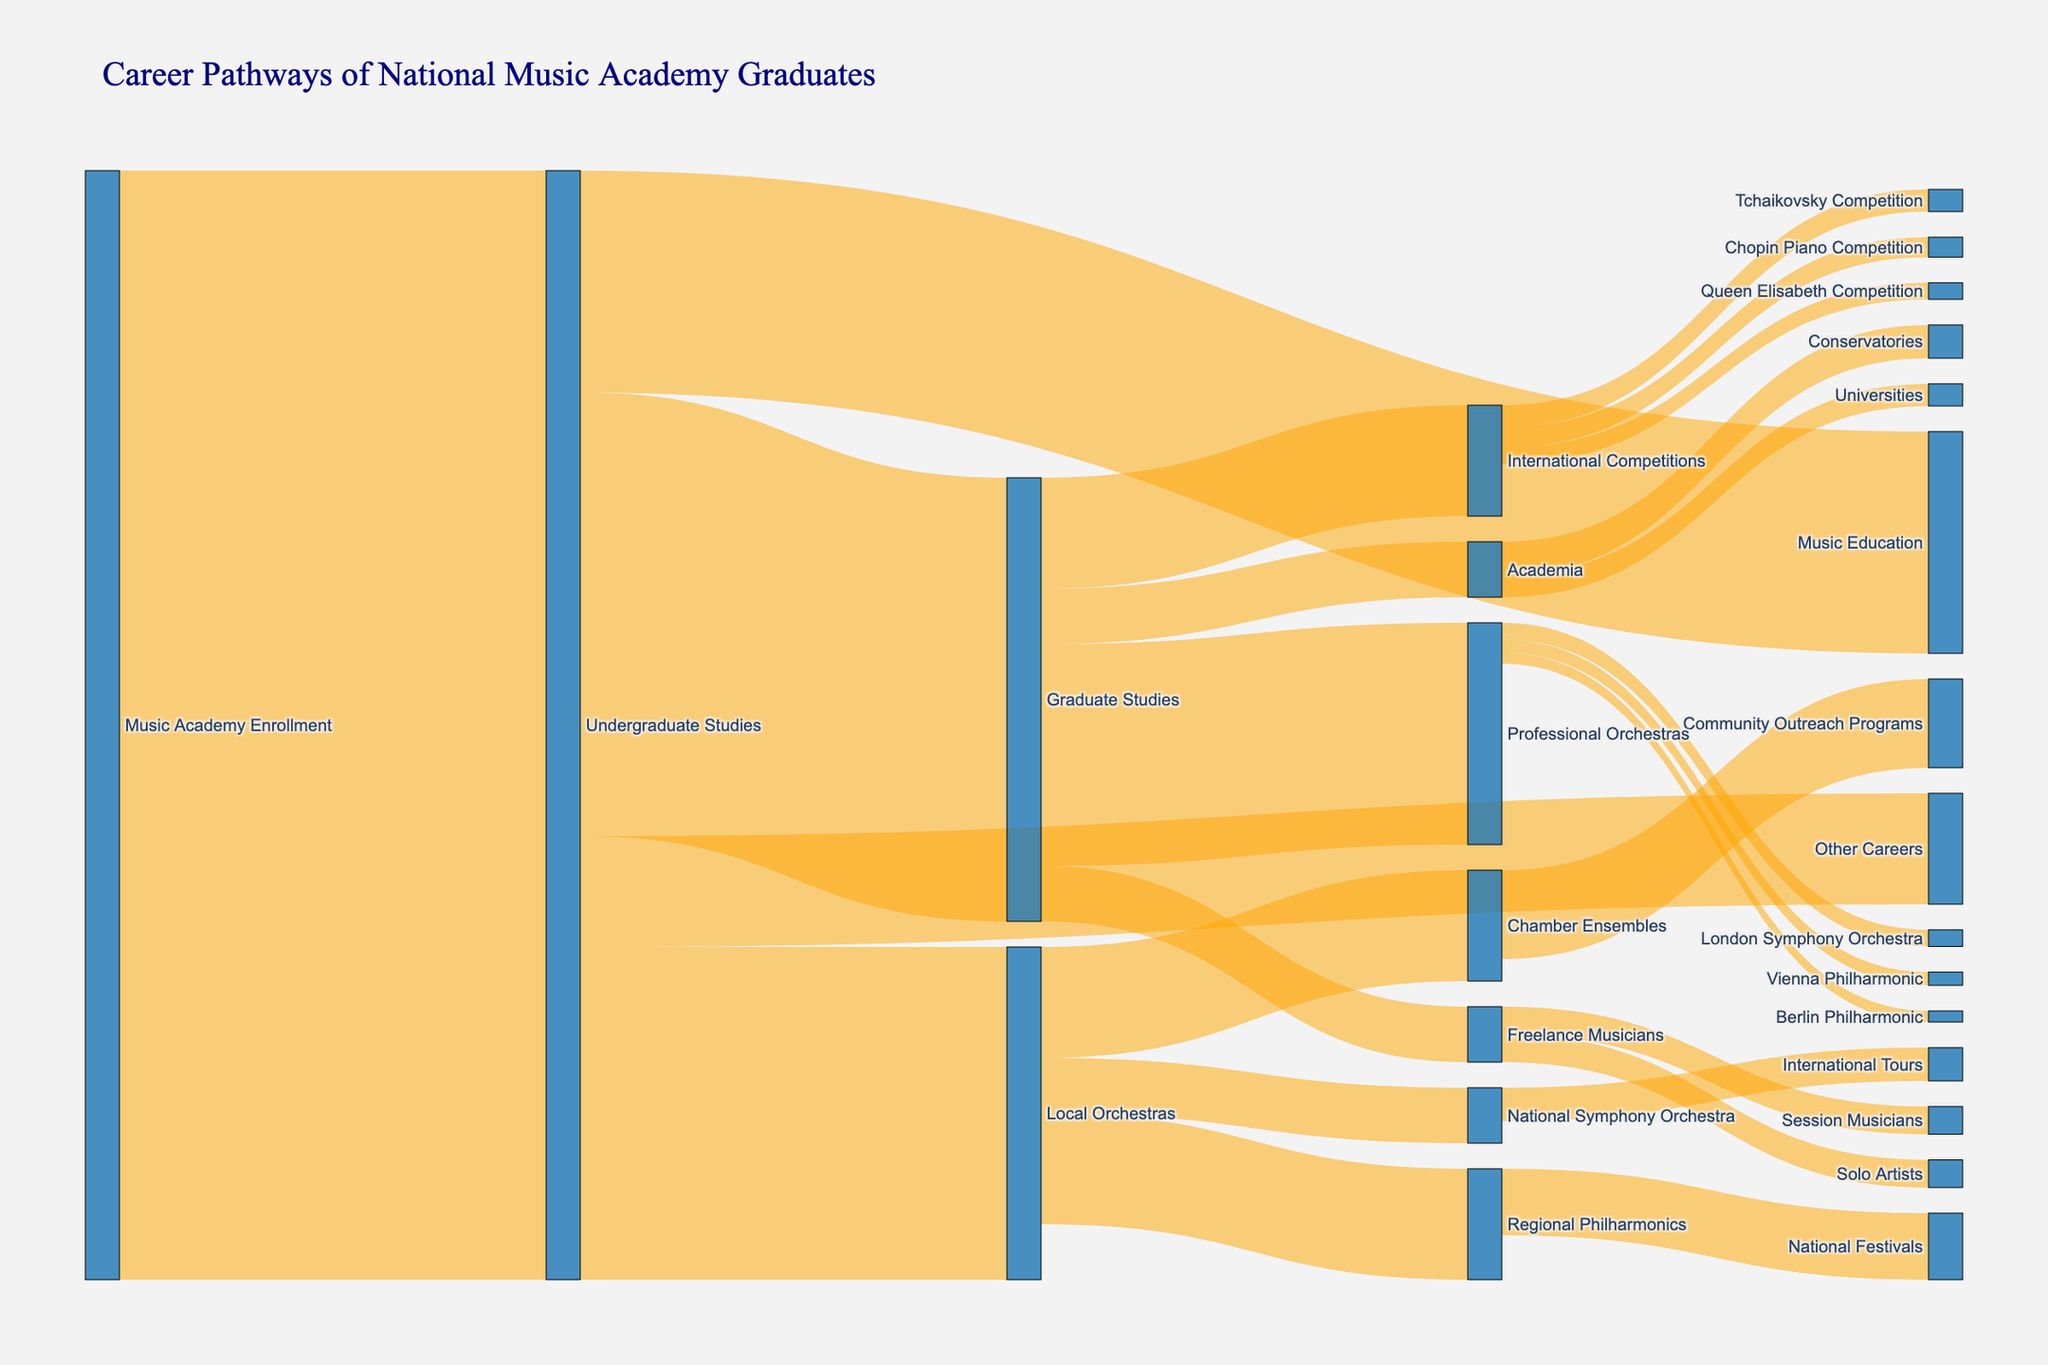What's the title of the figure? The title is at the top of the figure, usually in a larger font size and different color to stand out. It serves as a summary of what the diagram is about.
Answer: Career Pathways of National Music Academy Graduates What's the total number of graduates who pursued Music Education after their undergraduate studies? To find this, look under the "Undergraduate Studies" node and add the value that leads to "Music Education."
Answer: 200 How many graduates moved from Local Orchestras to National Symphony Orchestra? Follow the link from "Local Orchestras" to "National Symphony Orchestra" and read the value associated with that link.
Answer: 50 What is the total number of graduates who joined Professional Orchestras after Graduate Studies? To find this, find the node "Graduate Studies" and sum the values of all links targeting "Professional Orchestras."
Answer: 200 How many graduates advanced from International Competitions to the Tchaikovsky Competition? Locate the "International Competitions" node and find the link that goes to "Tchaikovsky Competition," then note its value.
Answer: 20 Which path has a higher number of graduates: Undergraduate Studies to Local Orchestras or Undergraduate Studies to Other Careers? Compare the values of the links from "Undergraduate Studies" to "Local Orchestras" and to "Other Careers."
Answer: Local Orchestras What is the sum of graduates that entered Conservatories and Universities from Academia? Identify the values of links from "Academia" to both "Conservatories" and "Universities" and add them up.
Answer: 50 How does the number of graduates in Regional Philharmonics compare to those in Chamber Ensembles from Local Orchestras? Examine the values of the links from "Local Orchestras" to "Regional Philharmonics" and "Chamber Ensembles" and compare them.
Answer: Equal What percentage of graduates went from International Competitions to Queen Elisabeth Competition? Take the value of graduates going to "Queen Elisabeth Competition" and divide by the total number from "International Competitions," then multiply by 100.
Answer: 15% Which international orchestra attracts the most graduates from Professional Orchestras? Look at links from "Professional Orchestras" to each international orchestra node, then identify the one with the highest value.
Answer: London Symphony Orchestra 